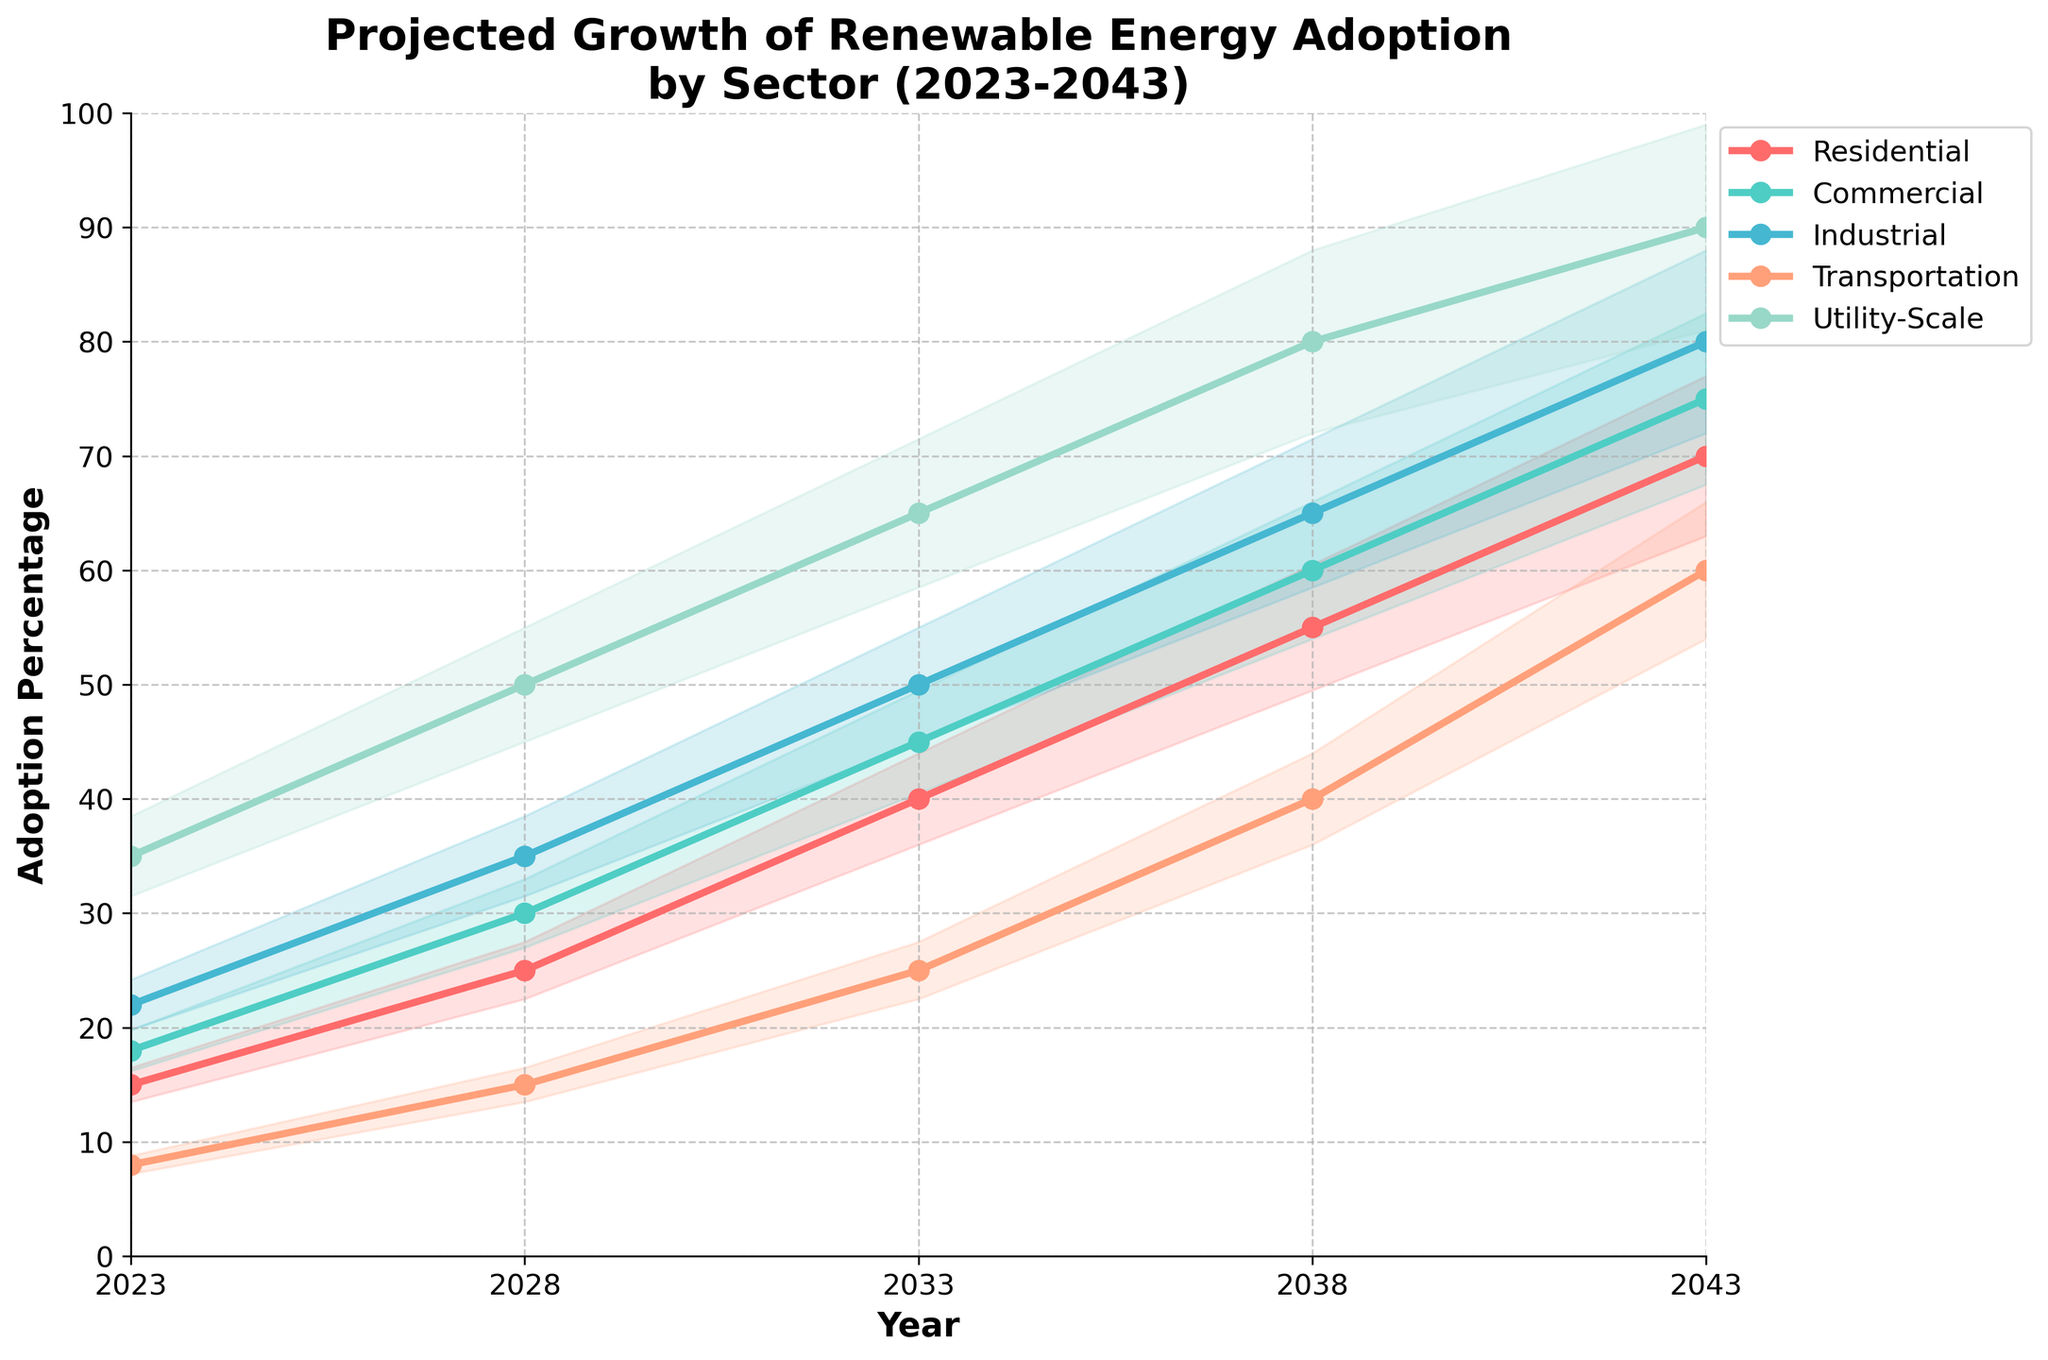What is the title of the plot? The title is placed at the top of the figure and is written directly on it. The title is 'Projected Growth of Renewable Energy Adoption by Sector (2023-2043)'.
Answer: Projected Growth of Renewable Energy Adoption by Sector (2023-2043) What sectors are included in the chart? The sectors are represented by different lines and labeled in the legend. The sectors include Residential, Commercial, Industrial, Transportation, and Utility-Scale.
Answer: Residential, Commercial, Industrial, Transportation, Utility-Scale Which sector is projected to have the highest adoption percentage in 2043? By looking at the values of each line at the year 2043, we see that the Utility-Scale sector has the highest projected adoption percentage at 90%.
Answer: Utility-Scale How does the adoption percentage for the Industrial sector change from 2023 to 2033? Looking at the Industrial sector line, the percentage goes from 22% in 2023 to 50% in 2033. The difference can be calculated as 50 - 22 = 28%.
Answer: 28% Between which two consecutive periods does the Transportation sector show the greatest increase? By checking each segment of the Transportation sector line, we observe the differences: 
From 2023 to 2028: 15 - 8 = 7 
From 2028 to 2033: 25 - 15 = 10 
From 2033 to 2038: 40 - 25 = 15 
From 2038 to 2043: 60 - 40 = 20 
The greatest increase is between 2038 and 2043, where the increase is 20.
Answer: 2038-2043 What is the range of the confidence interval for the Commercial sector in 2033? For the Commercial sector in 2033, the percentage is 45%. The confidence interval is ±10%, so the lower limit is 45 * 0.9 = 40.5% and the upper limit is 45 * 1.1 = 49.5%. The range is from 40.5% to 49.5%.
Answer: 40.5% to 49.5% Which sector shows the smallest projected increase from 2023 to 2043? Calculating the increase for each sector:
Residential: 70 - 15 = 55
Commercial: 75 - 18 = 57
Industrial: 80 - 22 = 58
Transportation: 60 - 8 = 52
Utility-Scale: 90 - 35 = 55
The Transportation sector shows the smallest increase at 52%.
Answer: Transportation At what year does the Residential sector surpass a 50% adoption rate? Looking at the Residential sector line, it surpasses 50% at the year 2038.
Answer: 2038 Which sector has the widest confidence interval in 2043? The confidence interval is proportional to the sector's percentage value. In 2043, Utility-Scale is the sector with the highest value at 90%, so it has the widest confidence interval.
Answer: Utility-Scale 